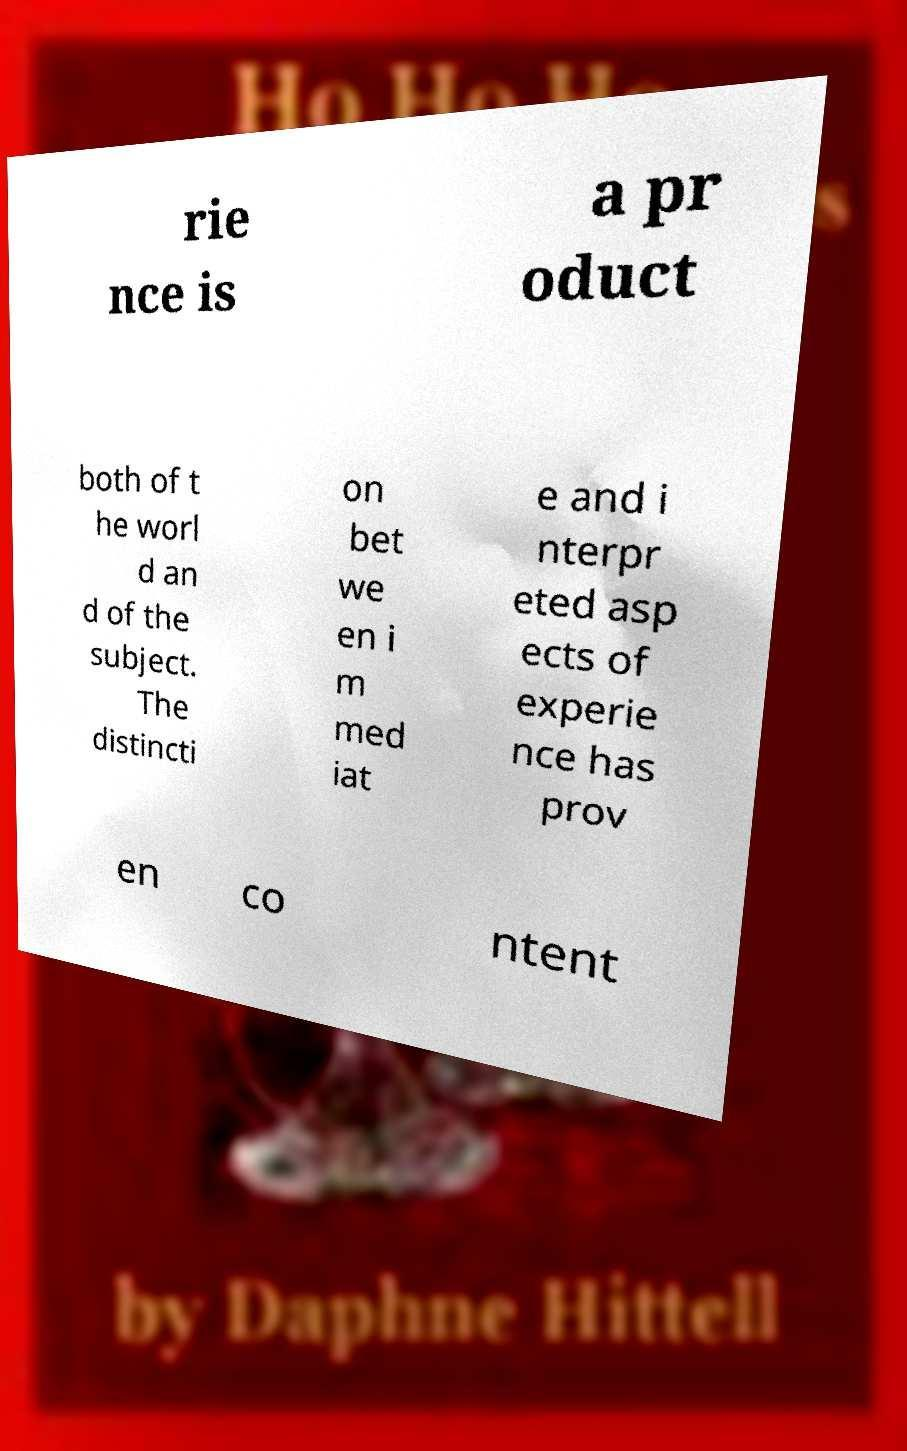There's text embedded in this image that I need extracted. Can you transcribe it verbatim? rie nce is a pr oduct both of t he worl d an d of the subject. The distincti on bet we en i m med iat e and i nterpr eted asp ects of experie nce has prov en co ntent 